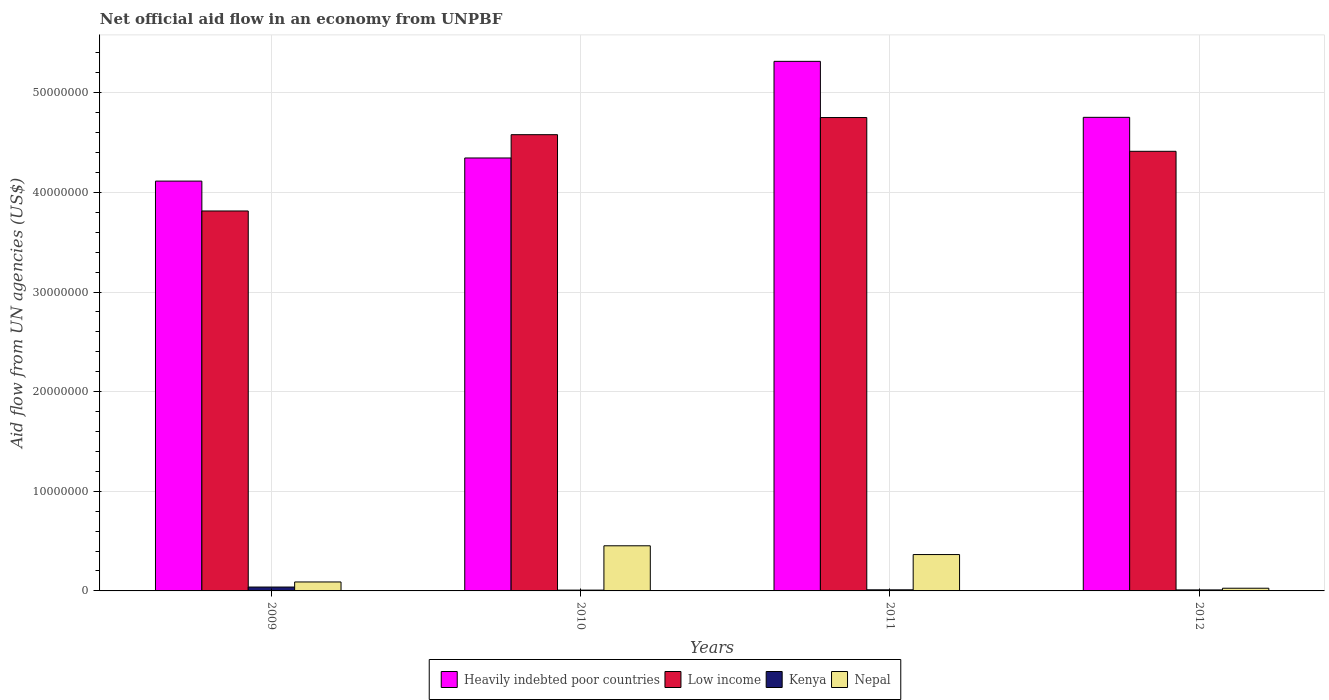How many groups of bars are there?
Give a very brief answer. 4. Are the number of bars per tick equal to the number of legend labels?
Your answer should be compact. Yes. Are the number of bars on each tick of the X-axis equal?
Give a very brief answer. Yes. What is the net official aid flow in Low income in 2011?
Make the answer very short. 4.75e+07. Across all years, what is the maximum net official aid flow in Nepal?
Offer a terse response. 4.53e+06. Across all years, what is the minimum net official aid flow in Low income?
Offer a very short reply. 3.81e+07. What is the total net official aid flow in Kenya in the graph?
Offer a terse response. 6.80e+05. What is the difference between the net official aid flow in Kenya in 2010 and that in 2011?
Keep it short and to the point. -3.00e+04. What is the difference between the net official aid flow in Low income in 2011 and the net official aid flow in Nepal in 2010?
Offer a very short reply. 4.30e+07. What is the average net official aid flow in Low income per year?
Ensure brevity in your answer.  4.39e+07. In the year 2010, what is the difference between the net official aid flow in Nepal and net official aid flow in Kenya?
Provide a succinct answer. 4.45e+06. In how many years, is the net official aid flow in Kenya greater than 14000000 US$?
Make the answer very short. 0. What is the ratio of the net official aid flow in Low income in 2010 to that in 2011?
Give a very brief answer. 0.96. Is the net official aid flow in Nepal in 2010 less than that in 2012?
Your response must be concise. No. What is the difference between the highest and the lowest net official aid flow in Low income?
Your answer should be very brief. 9.38e+06. What does the 1st bar from the left in 2009 represents?
Provide a short and direct response. Heavily indebted poor countries. What does the 1st bar from the right in 2011 represents?
Make the answer very short. Nepal. Is it the case that in every year, the sum of the net official aid flow in Kenya and net official aid flow in Low income is greater than the net official aid flow in Nepal?
Ensure brevity in your answer.  Yes. How many bars are there?
Your answer should be compact. 16. How many years are there in the graph?
Give a very brief answer. 4. Are the values on the major ticks of Y-axis written in scientific E-notation?
Provide a short and direct response. No. Does the graph contain grids?
Your response must be concise. Yes. Where does the legend appear in the graph?
Make the answer very short. Bottom center. What is the title of the graph?
Offer a terse response. Net official aid flow in an economy from UNPBF. Does "St. Vincent and the Grenadines" appear as one of the legend labels in the graph?
Give a very brief answer. No. What is the label or title of the Y-axis?
Offer a very short reply. Aid flow from UN agencies (US$). What is the Aid flow from UN agencies (US$) in Heavily indebted poor countries in 2009?
Provide a succinct answer. 4.11e+07. What is the Aid flow from UN agencies (US$) in Low income in 2009?
Ensure brevity in your answer.  3.81e+07. What is the Aid flow from UN agencies (US$) of Kenya in 2009?
Offer a terse response. 3.90e+05. What is the Aid flow from UN agencies (US$) in Heavily indebted poor countries in 2010?
Your response must be concise. 4.35e+07. What is the Aid flow from UN agencies (US$) in Low income in 2010?
Give a very brief answer. 4.58e+07. What is the Aid flow from UN agencies (US$) of Nepal in 2010?
Provide a short and direct response. 4.53e+06. What is the Aid flow from UN agencies (US$) in Heavily indebted poor countries in 2011?
Ensure brevity in your answer.  5.32e+07. What is the Aid flow from UN agencies (US$) in Low income in 2011?
Provide a succinct answer. 4.75e+07. What is the Aid flow from UN agencies (US$) in Kenya in 2011?
Provide a short and direct response. 1.10e+05. What is the Aid flow from UN agencies (US$) in Nepal in 2011?
Your answer should be very brief. 3.65e+06. What is the Aid flow from UN agencies (US$) of Heavily indebted poor countries in 2012?
Ensure brevity in your answer.  4.75e+07. What is the Aid flow from UN agencies (US$) in Low income in 2012?
Offer a very short reply. 4.41e+07. What is the Aid flow from UN agencies (US$) in Kenya in 2012?
Offer a very short reply. 1.00e+05. What is the Aid flow from UN agencies (US$) of Nepal in 2012?
Provide a short and direct response. 2.70e+05. Across all years, what is the maximum Aid flow from UN agencies (US$) of Heavily indebted poor countries?
Make the answer very short. 5.32e+07. Across all years, what is the maximum Aid flow from UN agencies (US$) of Low income?
Your answer should be very brief. 4.75e+07. Across all years, what is the maximum Aid flow from UN agencies (US$) in Nepal?
Provide a succinct answer. 4.53e+06. Across all years, what is the minimum Aid flow from UN agencies (US$) in Heavily indebted poor countries?
Provide a short and direct response. 4.11e+07. Across all years, what is the minimum Aid flow from UN agencies (US$) of Low income?
Your answer should be very brief. 3.81e+07. Across all years, what is the minimum Aid flow from UN agencies (US$) of Nepal?
Your response must be concise. 2.70e+05. What is the total Aid flow from UN agencies (US$) in Heavily indebted poor countries in the graph?
Your answer should be very brief. 1.85e+08. What is the total Aid flow from UN agencies (US$) of Low income in the graph?
Offer a very short reply. 1.76e+08. What is the total Aid flow from UN agencies (US$) of Kenya in the graph?
Your answer should be compact. 6.80e+05. What is the total Aid flow from UN agencies (US$) of Nepal in the graph?
Offer a terse response. 9.35e+06. What is the difference between the Aid flow from UN agencies (US$) in Heavily indebted poor countries in 2009 and that in 2010?
Make the answer very short. -2.32e+06. What is the difference between the Aid flow from UN agencies (US$) in Low income in 2009 and that in 2010?
Ensure brevity in your answer.  -7.66e+06. What is the difference between the Aid flow from UN agencies (US$) in Nepal in 2009 and that in 2010?
Ensure brevity in your answer.  -3.63e+06. What is the difference between the Aid flow from UN agencies (US$) in Heavily indebted poor countries in 2009 and that in 2011?
Provide a short and direct response. -1.20e+07. What is the difference between the Aid flow from UN agencies (US$) of Low income in 2009 and that in 2011?
Your answer should be very brief. -9.38e+06. What is the difference between the Aid flow from UN agencies (US$) of Kenya in 2009 and that in 2011?
Give a very brief answer. 2.80e+05. What is the difference between the Aid flow from UN agencies (US$) in Nepal in 2009 and that in 2011?
Your answer should be very brief. -2.75e+06. What is the difference between the Aid flow from UN agencies (US$) of Heavily indebted poor countries in 2009 and that in 2012?
Offer a very short reply. -6.40e+06. What is the difference between the Aid flow from UN agencies (US$) of Low income in 2009 and that in 2012?
Offer a very short reply. -5.99e+06. What is the difference between the Aid flow from UN agencies (US$) of Nepal in 2009 and that in 2012?
Your answer should be compact. 6.30e+05. What is the difference between the Aid flow from UN agencies (US$) of Heavily indebted poor countries in 2010 and that in 2011?
Make the answer very short. -9.70e+06. What is the difference between the Aid flow from UN agencies (US$) in Low income in 2010 and that in 2011?
Your response must be concise. -1.72e+06. What is the difference between the Aid flow from UN agencies (US$) of Kenya in 2010 and that in 2011?
Your answer should be very brief. -3.00e+04. What is the difference between the Aid flow from UN agencies (US$) in Nepal in 2010 and that in 2011?
Keep it short and to the point. 8.80e+05. What is the difference between the Aid flow from UN agencies (US$) in Heavily indebted poor countries in 2010 and that in 2012?
Your answer should be very brief. -4.08e+06. What is the difference between the Aid flow from UN agencies (US$) in Low income in 2010 and that in 2012?
Give a very brief answer. 1.67e+06. What is the difference between the Aid flow from UN agencies (US$) in Nepal in 2010 and that in 2012?
Ensure brevity in your answer.  4.26e+06. What is the difference between the Aid flow from UN agencies (US$) of Heavily indebted poor countries in 2011 and that in 2012?
Your answer should be compact. 5.62e+06. What is the difference between the Aid flow from UN agencies (US$) in Low income in 2011 and that in 2012?
Keep it short and to the point. 3.39e+06. What is the difference between the Aid flow from UN agencies (US$) of Kenya in 2011 and that in 2012?
Your response must be concise. 10000. What is the difference between the Aid flow from UN agencies (US$) of Nepal in 2011 and that in 2012?
Ensure brevity in your answer.  3.38e+06. What is the difference between the Aid flow from UN agencies (US$) in Heavily indebted poor countries in 2009 and the Aid flow from UN agencies (US$) in Low income in 2010?
Provide a succinct answer. -4.66e+06. What is the difference between the Aid flow from UN agencies (US$) of Heavily indebted poor countries in 2009 and the Aid flow from UN agencies (US$) of Kenya in 2010?
Keep it short and to the point. 4.11e+07. What is the difference between the Aid flow from UN agencies (US$) in Heavily indebted poor countries in 2009 and the Aid flow from UN agencies (US$) in Nepal in 2010?
Your answer should be compact. 3.66e+07. What is the difference between the Aid flow from UN agencies (US$) in Low income in 2009 and the Aid flow from UN agencies (US$) in Kenya in 2010?
Keep it short and to the point. 3.81e+07. What is the difference between the Aid flow from UN agencies (US$) of Low income in 2009 and the Aid flow from UN agencies (US$) of Nepal in 2010?
Keep it short and to the point. 3.36e+07. What is the difference between the Aid flow from UN agencies (US$) in Kenya in 2009 and the Aid flow from UN agencies (US$) in Nepal in 2010?
Ensure brevity in your answer.  -4.14e+06. What is the difference between the Aid flow from UN agencies (US$) of Heavily indebted poor countries in 2009 and the Aid flow from UN agencies (US$) of Low income in 2011?
Offer a terse response. -6.38e+06. What is the difference between the Aid flow from UN agencies (US$) of Heavily indebted poor countries in 2009 and the Aid flow from UN agencies (US$) of Kenya in 2011?
Your response must be concise. 4.10e+07. What is the difference between the Aid flow from UN agencies (US$) of Heavily indebted poor countries in 2009 and the Aid flow from UN agencies (US$) of Nepal in 2011?
Offer a terse response. 3.75e+07. What is the difference between the Aid flow from UN agencies (US$) of Low income in 2009 and the Aid flow from UN agencies (US$) of Kenya in 2011?
Your answer should be compact. 3.80e+07. What is the difference between the Aid flow from UN agencies (US$) of Low income in 2009 and the Aid flow from UN agencies (US$) of Nepal in 2011?
Your answer should be compact. 3.45e+07. What is the difference between the Aid flow from UN agencies (US$) of Kenya in 2009 and the Aid flow from UN agencies (US$) of Nepal in 2011?
Ensure brevity in your answer.  -3.26e+06. What is the difference between the Aid flow from UN agencies (US$) of Heavily indebted poor countries in 2009 and the Aid flow from UN agencies (US$) of Low income in 2012?
Ensure brevity in your answer.  -2.99e+06. What is the difference between the Aid flow from UN agencies (US$) of Heavily indebted poor countries in 2009 and the Aid flow from UN agencies (US$) of Kenya in 2012?
Offer a very short reply. 4.10e+07. What is the difference between the Aid flow from UN agencies (US$) of Heavily indebted poor countries in 2009 and the Aid flow from UN agencies (US$) of Nepal in 2012?
Your answer should be very brief. 4.09e+07. What is the difference between the Aid flow from UN agencies (US$) of Low income in 2009 and the Aid flow from UN agencies (US$) of Kenya in 2012?
Your response must be concise. 3.80e+07. What is the difference between the Aid flow from UN agencies (US$) of Low income in 2009 and the Aid flow from UN agencies (US$) of Nepal in 2012?
Offer a very short reply. 3.79e+07. What is the difference between the Aid flow from UN agencies (US$) of Kenya in 2009 and the Aid flow from UN agencies (US$) of Nepal in 2012?
Your answer should be compact. 1.20e+05. What is the difference between the Aid flow from UN agencies (US$) in Heavily indebted poor countries in 2010 and the Aid flow from UN agencies (US$) in Low income in 2011?
Give a very brief answer. -4.06e+06. What is the difference between the Aid flow from UN agencies (US$) of Heavily indebted poor countries in 2010 and the Aid flow from UN agencies (US$) of Kenya in 2011?
Provide a succinct answer. 4.34e+07. What is the difference between the Aid flow from UN agencies (US$) in Heavily indebted poor countries in 2010 and the Aid flow from UN agencies (US$) in Nepal in 2011?
Offer a terse response. 3.98e+07. What is the difference between the Aid flow from UN agencies (US$) in Low income in 2010 and the Aid flow from UN agencies (US$) in Kenya in 2011?
Keep it short and to the point. 4.57e+07. What is the difference between the Aid flow from UN agencies (US$) of Low income in 2010 and the Aid flow from UN agencies (US$) of Nepal in 2011?
Your answer should be very brief. 4.22e+07. What is the difference between the Aid flow from UN agencies (US$) in Kenya in 2010 and the Aid flow from UN agencies (US$) in Nepal in 2011?
Offer a very short reply. -3.57e+06. What is the difference between the Aid flow from UN agencies (US$) of Heavily indebted poor countries in 2010 and the Aid flow from UN agencies (US$) of Low income in 2012?
Your answer should be very brief. -6.70e+05. What is the difference between the Aid flow from UN agencies (US$) of Heavily indebted poor countries in 2010 and the Aid flow from UN agencies (US$) of Kenya in 2012?
Give a very brief answer. 4.34e+07. What is the difference between the Aid flow from UN agencies (US$) of Heavily indebted poor countries in 2010 and the Aid flow from UN agencies (US$) of Nepal in 2012?
Your response must be concise. 4.32e+07. What is the difference between the Aid flow from UN agencies (US$) in Low income in 2010 and the Aid flow from UN agencies (US$) in Kenya in 2012?
Your response must be concise. 4.57e+07. What is the difference between the Aid flow from UN agencies (US$) in Low income in 2010 and the Aid flow from UN agencies (US$) in Nepal in 2012?
Provide a succinct answer. 4.55e+07. What is the difference between the Aid flow from UN agencies (US$) in Kenya in 2010 and the Aid flow from UN agencies (US$) in Nepal in 2012?
Offer a very short reply. -1.90e+05. What is the difference between the Aid flow from UN agencies (US$) of Heavily indebted poor countries in 2011 and the Aid flow from UN agencies (US$) of Low income in 2012?
Your response must be concise. 9.03e+06. What is the difference between the Aid flow from UN agencies (US$) in Heavily indebted poor countries in 2011 and the Aid flow from UN agencies (US$) in Kenya in 2012?
Make the answer very short. 5.31e+07. What is the difference between the Aid flow from UN agencies (US$) in Heavily indebted poor countries in 2011 and the Aid flow from UN agencies (US$) in Nepal in 2012?
Keep it short and to the point. 5.29e+07. What is the difference between the Aid flow from UN agencies (US$) of Low income in 2011 and the Aid flow from UN agencies (US$) of Kenya in 2012?
Ensure brevity in your answer.  4.74e+07. What is the difference between the Aid flow from UN agencies (US$) of Low income in 2011 and the Aid flow from UN agencies (US$) of Nepal in 2012?
Keep it short and to the point. 4.72e+07. What is the average Aid flow from UN agencies (US$) in Heavily indebted poor countries per year?
Provide a short and direct response. 4.63e+07. What is the average Aid flow from UN agencies (US$) of Low income per year?
Keep it short and to the point. 4.39e+07. What is the average Aid flow from UN agencies (US$) of Nepal per year?
Offer a terse response. 2.34e+06. In the year 2009, what is the difference between the Aid flow from UN agencies (US$) in Heavily indebted poor countries and Aid flow from UN agencies (US$) in Low income?
Make the answer very short. 3.00e+06. In the year 2009, what is the difference between the Aid flow from UN agencies (US$) of Heavily indebted poor countries and Aid flow from UN agencies (US$) of Kenya?
Offer a terse response. 4.08e+07. In the year 2009, what is the difference between the Aid flow from UN agencies (US$) of Heavily indebted poor countries and Aid flow from UN agencies (US$) of Nepal?
Your answer should be very brief. 4.02e+07. In the year 2009, what is the difference between the Aid flow from UN agencies (US$) in Low income and Aid flow from UN agencies (US$) in Kenya?
Ensure brevity in your answer.  3.78e+07. In the year 2009, what is the difference between the Aid flow from UN agencies (US$) of Low income and Aid flow from UN agencies (US$) of Nepal?
Your answer should be compact. 3.72e+07. In the year 2009, what is the difference between the Aid flow from UN agencies (US$) of Kenya and Aid flow from UN agencies (US$) of Nepal?
Offer a very short reply. -5.10e+05. In the year 2010, what is the difference between the Aid flow from UN agencies (US$) of Heavily indebted poor countries and Aid flow from UN agencies (US$) of Low income?
Provide a short and direct response. -2.34e+06. In the year 2010, what is the difference between the Aid flow from UN agencies (US$) in Heavily indebted poor countries and Aid flow from UN agencies (US$) in Kenya?
Provide a succinct answer. 4.34e+07. In the year 2010, what is the difference between the Aid flow from UN agencies (US$) in Heavily indebted poor countries and Aid flow from UN agencies (US$) in Nepal?
Ensure brevity in your answer.  3.89e+07. In the year 2010, what is the difference between the Aid flow from UN agencies (US$) in Low income and Aid flow from UN agencies (US$) in Kenya?
Offer a very short reply. 4.57e+07. In the year 2010, what is the difference between the Aid flow from UN agencies (US$) in Low income and Aid flow from UN agencies (US$) in Nepal?
Offer a very short reply. 4.13e+07. In the year 2010, what is the difference between the Aid flow from UN agencies (US$) in Kenya and Aid flow from UN agencies (US$) in Nepal?
Make the answer very short. -4.45e+06. In the year 2011, what is the difference between the Aid flow from UN agencies (US$) of Heavily indebted poor countries and Aid flow from UN agencies (US$) of Low income?
Your answer should be very brief. 5.64e+06. In the year 2011, what is the difference between the Aid flow from UN agencies (US$) of Heavily indebted poor countries and Aid flow from UN agencies (US$) of Kenya?
Provide a short and direct response. 5.30e+07. In the year 2011, what is the difference between the Aid flow from UN agencies (US$) of Heavily indebted poor countries and Aid flow from UN agencies (US$) of Nepal?
Your answer should be compact. 4.95e+07. In the year 2011, what is the difference between the Aid flow from UN agencies (US$) in Low income and Aid flow from UN agencies (US$) in Kenya?
Offer a very short reply. 4.74e+07. In the year 2011, what is the difference between the Aid flow from UN agencies (US$) of Low income and Aid flow from UN agencies (US$) of Nepal?
Keep it short and to the point. 4.39e+07. In the year 2011, what is the difference between the Aid flow from UN agencies (US$) of Kenya and Aid flow from UN agencies (US$) of Nepal?
Your response must be concise. -3.54e+06. In the year 2012, what is the difference between the Aid flow from UN agencies (US$) in Heavily indebted poor countries and Aid flow from UN agencies (US$) in Low income?
Your answer should be compact. 3.41e+06. In the year 2012, what is the difference between the Aid flow from UN agencies (US$) of Heavily indebted poor countries and Aid flow from UN agencies (US$) of Kenya?
Offer a terse response. 4.74e+07. In the year 2012, what is the difference between the Aid flow from UN agencies (US$) of Heavily indebted poor countries and Aid flow from UN agencies (US$) of Nepal?
Your answer should be very brief. 4.73e+07. In the year 2012, what is the difference between the Aid flow from UN agencies (US$) of Low income and Aid flow from UN agencies (US$) of Kenya?
Offer a very short reply. 4.40e+07. In the year 2012, what is the difference between the Aid flow from UN agencies (US$) of Low income and Aid flow from UN agencies (US$) of Nepal?
Give a very brief answer. 4.39e+07. What is the ratio of the Aid flow from UN agencies (US$) in Heavily indebted poor countries in 2009 to that in 2010?
Your answer should be compact. 0.95. What is the ratio of the Aid flow from UN agencies (US$) of Low income in 2009 to that in 2010?
Give a very brief answer. 0.83. What is the ratio of the Aid flow from UN agencies (US$) of Kenya in 2009 to that in 2010?
Provide a short and direct response. 4.88. What is the ratio of the Aid flow from UN agencies (US$) of Nepal in 2009 to that in 2010?
Offer a terse response. 0.2. What is the ratio of the Aid flow from UN agencies (US$) in Heavily indebted poor countries in 2009 to that in 2011?
Offer a terse response. 0.77. What is the ratio of the Aid flow from UN agencies (US$) of Low income in 2009 to that in 2011?
Offer a terse response. 0.8. What is the ratio of the Aid flow from UN agencies (US$) of Kenya in 2009 to that in 2011?
Your answer should be very brief. 3.55. What is the ratio of the Aid flow from UN agencies (US$) of Nepal in 2009 to that in 2011?
Provide a short and direct response. 0.25. What is the ratio of the Aid flow from UN agencies (US$) in Heavily indebted poor countries in 2009 to that in 2012?
Offer a very short reply. 0.87. What is the ratio of the Aid flow from UN agencies (US$) of Low income in 2009 to that in 2012?
Ensure brevity in your answer.  0.86. What is the ratio of the Aid flow from UN agencies (US$) in Nepal in 2009 to that in 2012?
Offer a terse response. 3.33. What is the ratio of the Aid flow from UN agencies (US$) in Heavily indebted poor countries in 2010 to that in 2011?
Your answer should be very brief. 0.82. What is the ratio of the Aid flow from UN agencies (US$) of Low income in 2010 to that in 2011?
Ensure brevity in your answer.  0.96. What is the ratio of the Aid flow from UN agencies (US$) of Kenya in 2010 to that in 2011?
Offer a very short reply. 0.73. What is the ratio of the Aid flow from UN agencies (US$) of Nepal in 2010 to that in 2011?
Your response must be concise. 1.24. What is the ratio of the Aid flow from UN agencies (US$) of Heavily indebted poor countries in 2010 to that in 2012?
Your answer should be compact. 0.91. What is the ratio of the Aid flow from UN agencies (US$) of Low income in 2010 to that in 2012?
Keep it short and to the point. 1.04. What is the ratio of the Aid flow from UN agencies (US$) of Nepal in 2010 to that in 2012?
Offer a terse response. 16.78. What is the ratio of the Aid flow from UN agencies (US$) of Heavily indebted poor countries in 2011 to that in 2012?
Your response must be concise. 1.12. What is the ratio of the Aid flow from UN agencies (US$) in Low income in 2011 to that in 2012?
Offer a terse response. 1.08. What is the ratio of the Aid flow from UN agencies (US$) of Nepal in 2011 to that in 2012?
Provide a short and direct response. 13.52. What is the difference between the highest and the second highest Aid flow from UN agencies (US$) in Heavily indebted poor countries?
Offer a very short reply. 5.62e+06. What is the difference between the highest and the second highest Aid flow from UN agencies (US$) of Low income?
Your response must be concise. 1.72e+06. What is the difference between the highest and the second highest Aid flow from UN agencies (US$) in Kenya?
Give a very brief answer. 2.80e+05. What is the difference between the highest and the second highest Aid flow from UN agencies (US$) of Nepal?
Offer a terse response. 8.80e+05. What is the difference between the highest and the lowest Aid flow from UN agencies (US$) in Heavily indebted poor countries?
Offer a terse response. 1.20e+07. What is the difference between the highest and the lowest Aid flow from UN agencies (US$) of Low income?
Offer a terse response. 9.38e+06. What is the difference between the highest and the lowest Aid flow from UN agencies (US$) of Nepal?
Your answer should be compact. 4.26e+06. 